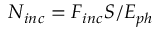Convert formula to latex. <formula><loc_0><loc_0><loc_500><loc_500>N _ { i n c } = F _ { i n c } S / E _ { p h }</formula> 